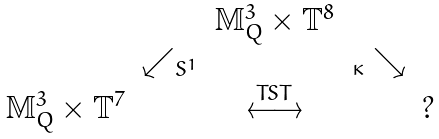Convert formula to latex. <formula><loc_0><loc_0><loc_500><loc_500>\begin{array} { c c c c c } & & \mathbb { M } _ { Q } ^ { 3 } \times \mathbb { T } ^ { 8 } & & \\ & \swarrow _ { S ^ { 1 } } & & _ { \kappa } \searrow & \\ \mathbb { M } _ { Q } ^ { 3 } \times \mathbb { T } ^ { 7 } & & \overset { T S T } { \longleftrightarrow } & & ? \end{array}</formula> 